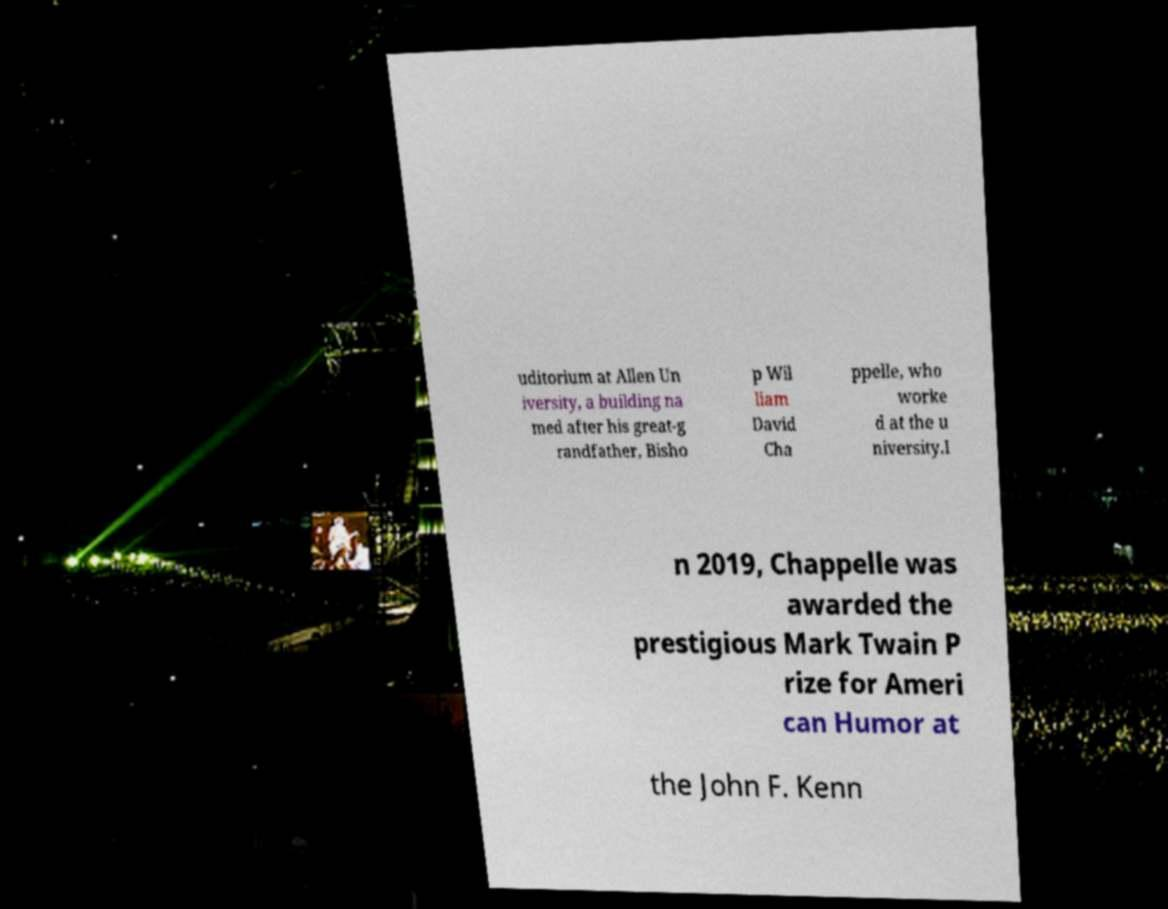Can you accurately transcribe the text from the provided image for me? uditorium at Allen Un iversity, a building na med after his great-g randfather, Bisho p Wil liam David Cha ppelle, who worke d at the u niversity.I n 2019, Chappelle was awarded the prestigious Mark Twain P rize for Ameri can Humor at the John F. Kenn 